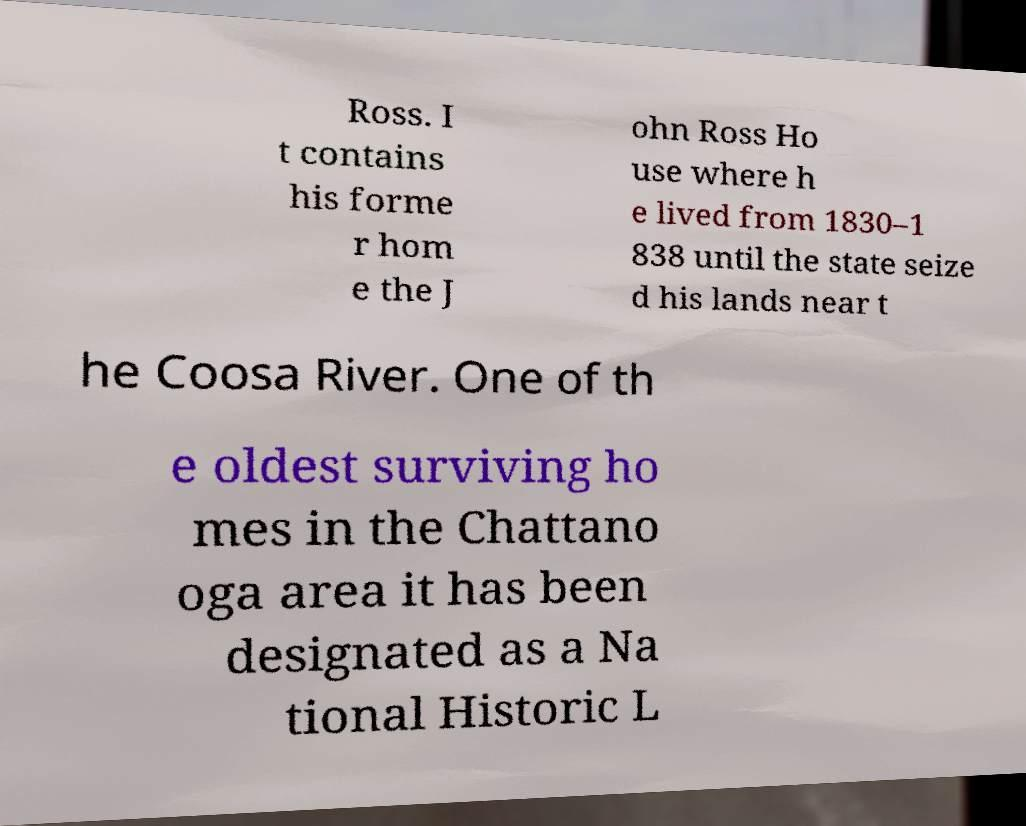Could you assist in decoding the text presented in this image and type it out clearly? Ross. I t contains his forme r hom e the J ohn Ross Ho use where h e lived from 1830–1 838 until the state seize d his lands near t he Coosa River. One of th e oldest surviving ho mes in the Chattano oga area it has been designated as a Na tional Historic L 